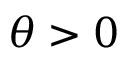<formula> <loc_0><loc_0><loc_500><loc_500>\theta > 0</formula> 